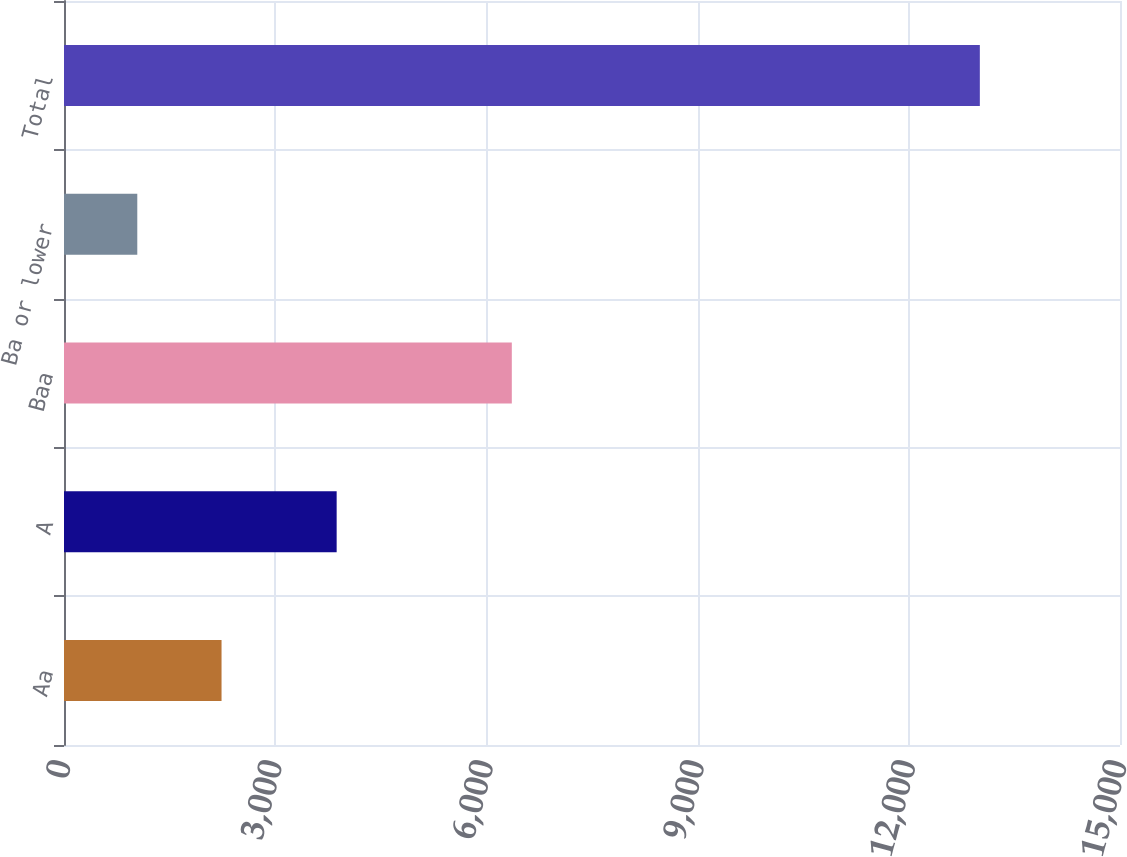<chart> <loc_0><loc_0><loc_500><loc_500><bar_chart><fcel>Aa<fcel>A<fcel>Baa<fcel>Ba or lower<fcel>Total<nl><fcel>2237.8<fcel>3873<fcel>6361<fcel>1041<fcel>13009<nl></chart> 